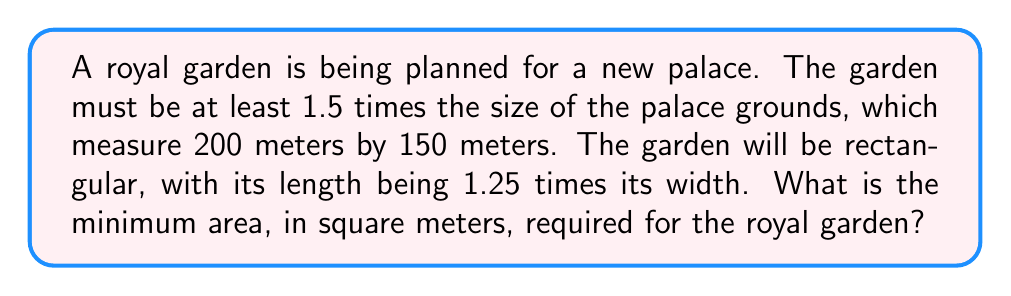What is the answer to this math problem? Let's approach this step-by-step:

1) First, calculate the area of the palace grounds:
   $$ A_{palace} = 200 \text{ m} \times 150 \text{ m} = 30,000 \text{ m}^2 $$

2) The garden must be at least 1.5 times this size:
   $$ A_{garden} \geq 1.5 \times 30,000 \text{ m}^2 = 45,000 \text{ m}^2 $$

3) Let's denote the width of the garden as $w$ and the length as $l$. We're told that:
   $$ l = 1.25w $$

4) The area of a rectangle is length times width, so:
   $$ A_{garden} = l \times w = 1.25w \times w = 1.25w^2 $$

5) We want the minimum area that satisfies the inequality:
   $$ 1.25w^2 \geq 45,000 \text{ m}^2 $$

6) Solve for $w$:
   $$ w^2 \geq \frac{45,000}{1.25} = 36,000 $$
   $$ w \geq \sqrt{36,000} = 189.74 \text{ m} $$

7) The minimum width is 189.74 m. The corresponding length is:
   $$ l = 1.25 \times 189.74 \text{ m} = 237.17 \text{ m} $$

8) Therefore, the minimum area is:
   $$ A_{min} = 189.74 \text{ m} \times 237.17 \text{ m} = 45,000 \text{ m}^2 $$
Answer: 45,000 m² 